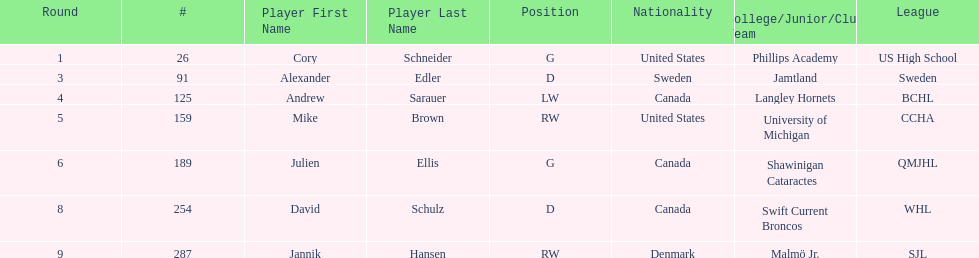How many canadian players are listed? 3. 